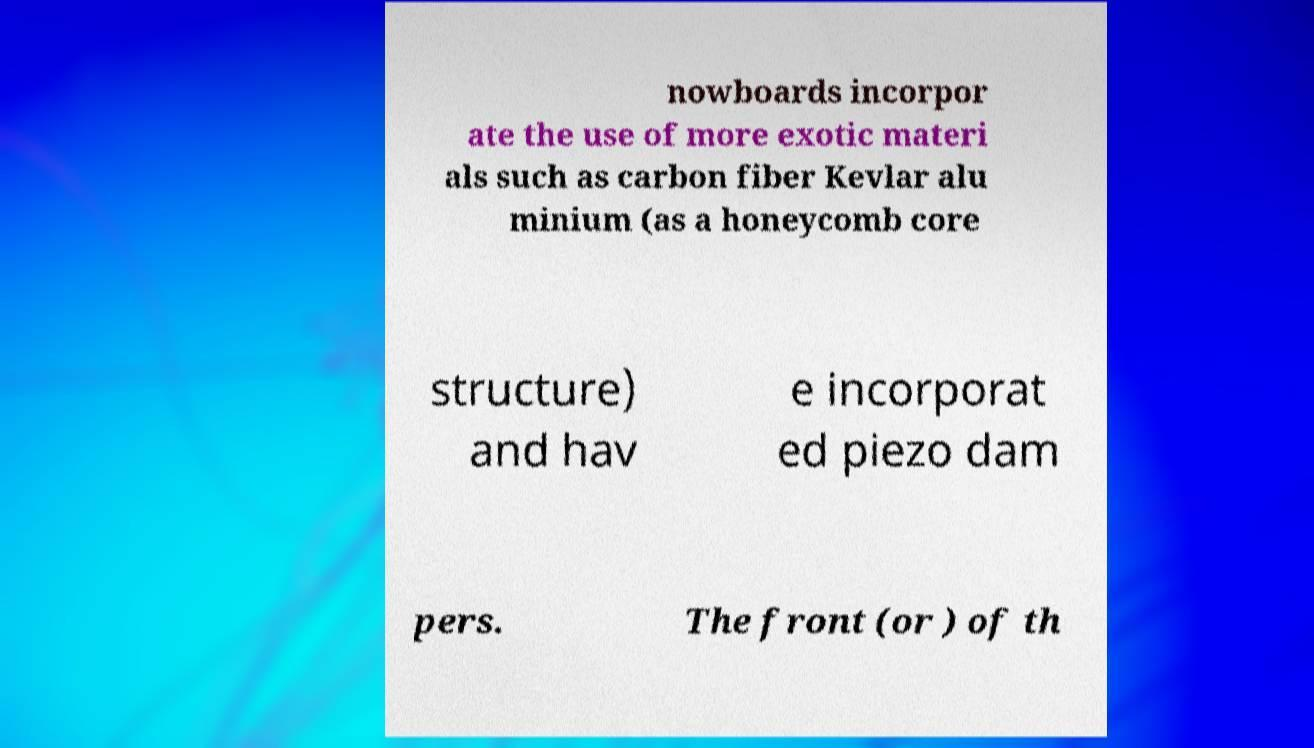Could you assist in decoding the text presented in this image and type it out clearly? nowboards incorpor ate the use of more exotic materi als such as carbon fiber Kevlar alu minium (as a honeycomb core structure) and hav e incorporat ed piezo dam pers. The front (or ) of th 